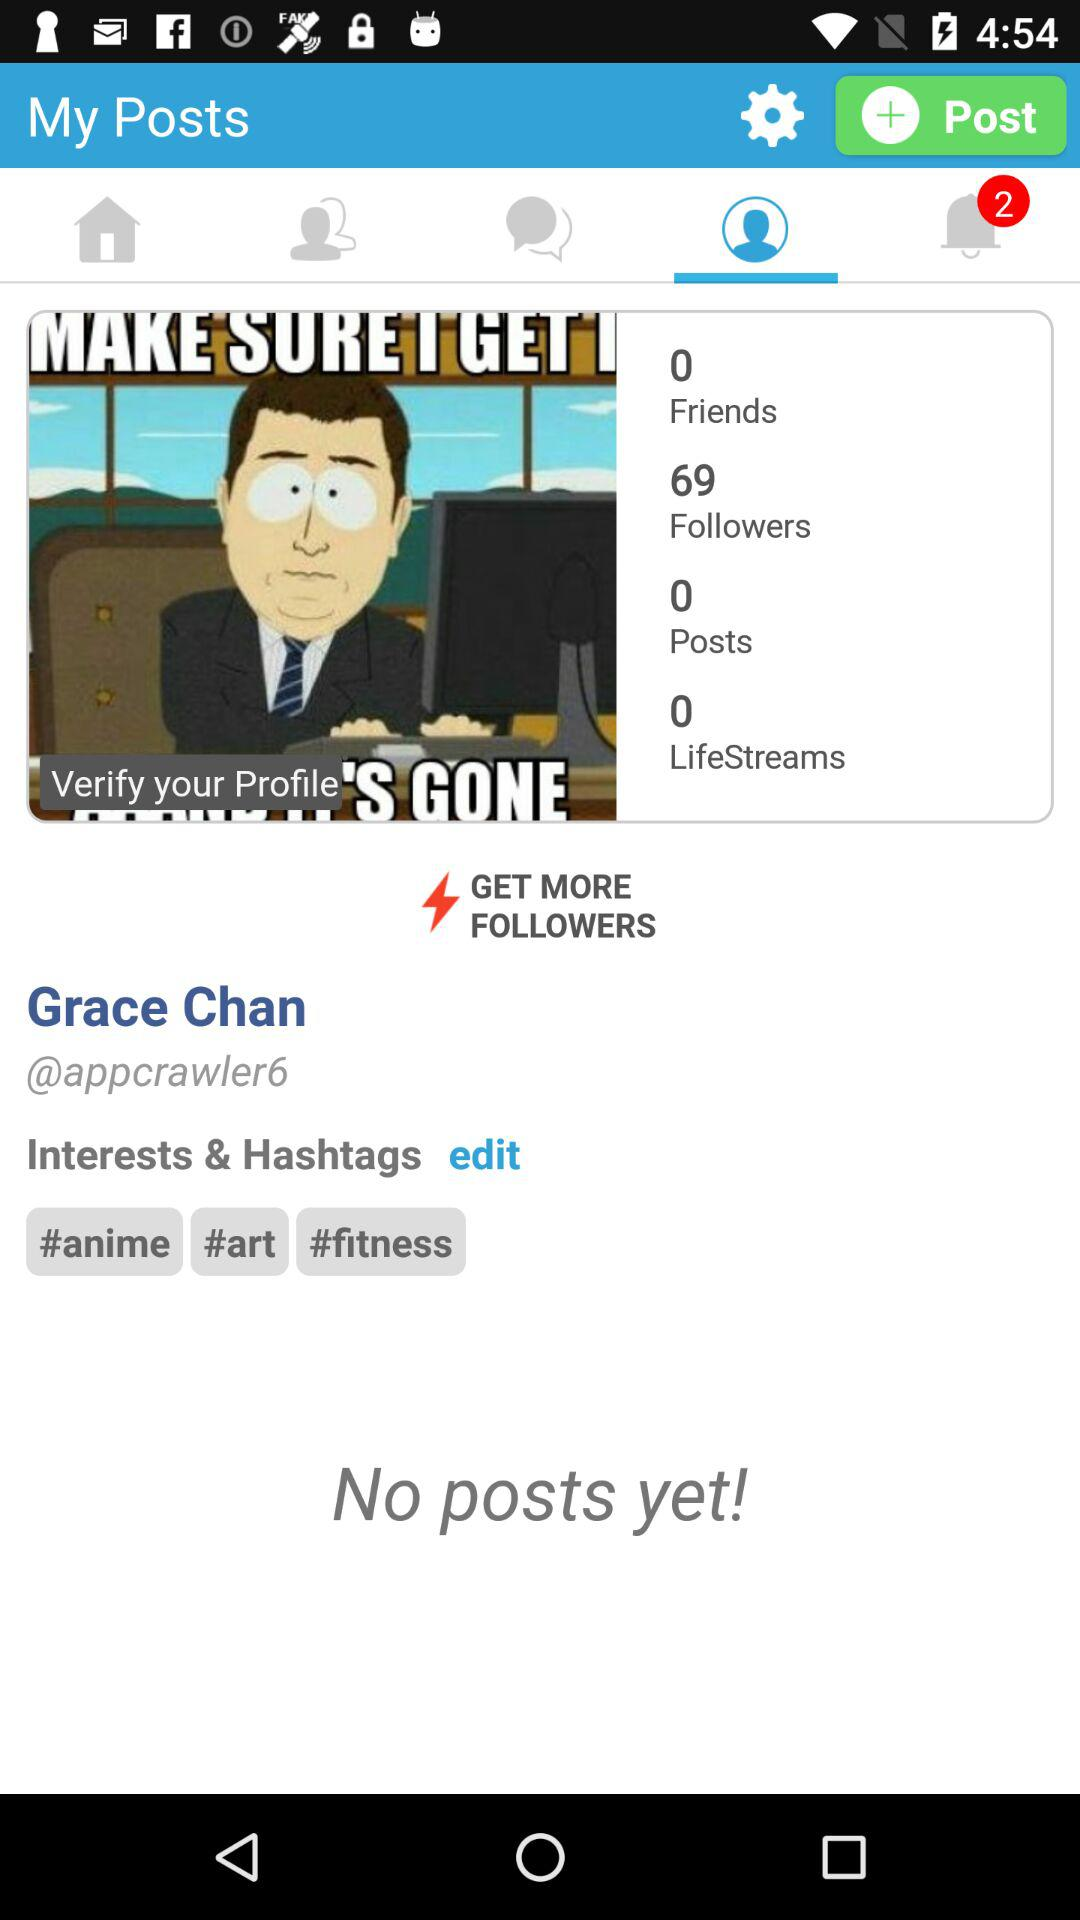What does the meme say?
When the provided information is insufficient, respond with <no answer>. <no answer> 